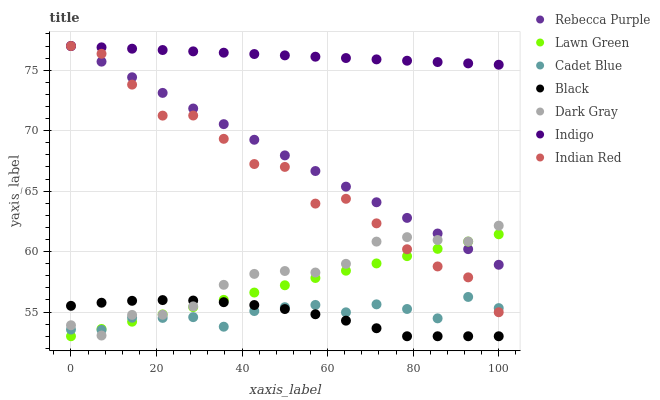Does Black have the minimum area under the curve?
Answer yes or no. Yes. Does Indigo have the maximum area under the curve?
Answer yes or no. Yes. Does Cadet Blue have the minimum area under the curve?
Answer yes or no. No. Does Cadet Blue have the maximum area under the curve?
Answer yes or no. No. Is Lawn Green the smoothest?
Answer yes or no. Yes. Is Indian Red the roughest?
Answer yes or no. Yes. Is Cadet Blue the smoothest?
Answer yes or no. No. Is Cadet Blue the roughest?
Answer yes or no. No. Does Lawn Green have the lowest value?
Answer yes or no. Yes. Does Cadet Blue have the lowest value?
Answer yes or no. No. Does Indian Red have the highest value?
Answer yes or no. Yes. Does Cadet Blue have the highest value?
Answer yes or no. No. Is Lawn Green less than Indigo?
Answer yes or no. Yes. Is Rebecca Purple greater than Black?
Answer yes or no. Yes. Does Lawn Green intersect Dark Gray?
Answer yes or no. Yes. Is Lawn Green less than Dark Gray?
Answer yes or no. No. Is Lawn Green greater than Dark Gray?
Answer yes or no. No. Does Lawn Green intersect Indigo?
Answer yes or no. No. 